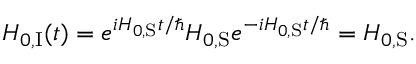<formula> <loc_0><loc_0><loc_500><loc_500>H _ { 0 , { I } } ( t ) = e ^ { i H _ { 0 , { S } } t / } H _ { 0 , { S } } e ^ { - i H _ { 0 , { S } } t / } = H _ { 0 , { S } } .</formula> 